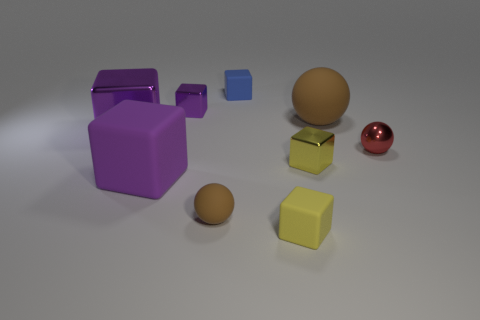What does the presence of both floating and resting shapes suggest? The contrast between floating and resting shapes could suggest multiple levels of interpretation. Aesthetically, it may create a dynamic visual that demonstrates balance and diversity in design. Metaphorically, it could signify concepts like gravity defiance or the transcendence of ideas. It's a visual play between the ordinary and the unexpected. 